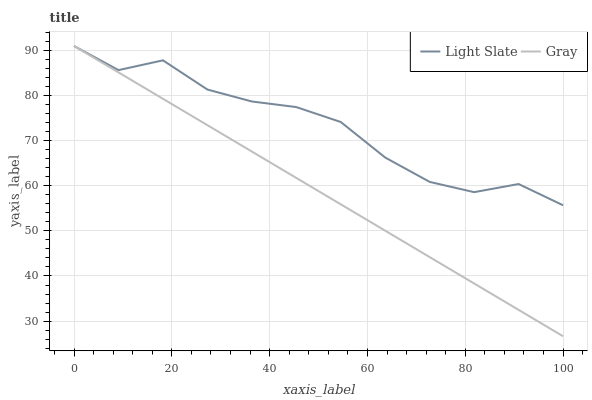Does Gray have the maximum area under the curve?
Answer yes or no. No. Is Gray the roughest?
Answer yes or no. No. 